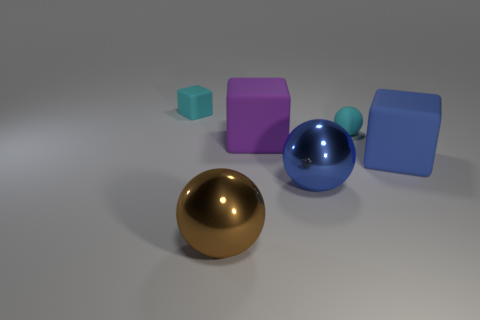Add 1 large purple metal cubes. How many objects exist? 7 Subtract all small cyan cubes. Subtract all tiny matte cubes. How many objects are left? 4 Add 3 small spheres. How many small spheres are left? 4 Add 2 big blue shiny cylinders. How many big blue shiny cylinders exist? 2 Subtract 0 brown cylinders. How many objects are left? 6 